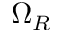<formula> <loc_0><loc_0><loc_500><loc_500>\Omega _ { R }</formula> 